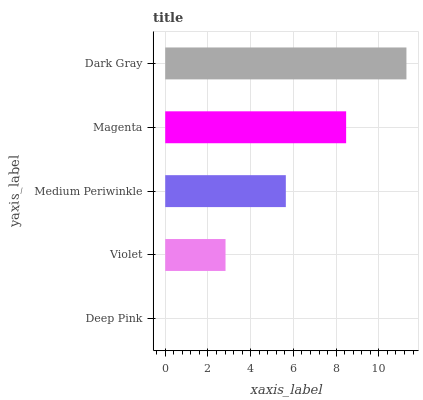Is Deep Pink the minimum?
Answer yes or no. Yes. Is Dark Gray the maximum?
Answer yes or no. Yes. Is Violet the minimum?
Answer yes or no. No. Is Violet the maximum?
Answer yes or no. No. Is Violet greater than Deep Pink?
Answer yes or no. Yes. Is Deep Pink less than Violet?
Answer yes or no. Yes. Is Deep Pink greater than Violet?
Answer yes or no. No. Is Violet less than Deep Pink?
Answer yes or no. No. Is Medium Periwinkle the high median?
Answer yes or no. Yes. Is Medium Periwinkle the low median?
Answer yes or no. Yes. Is Deep Pink the high median?
Answer yes or no. No. Is Magenta the low median?
Answer yes or no. No. 